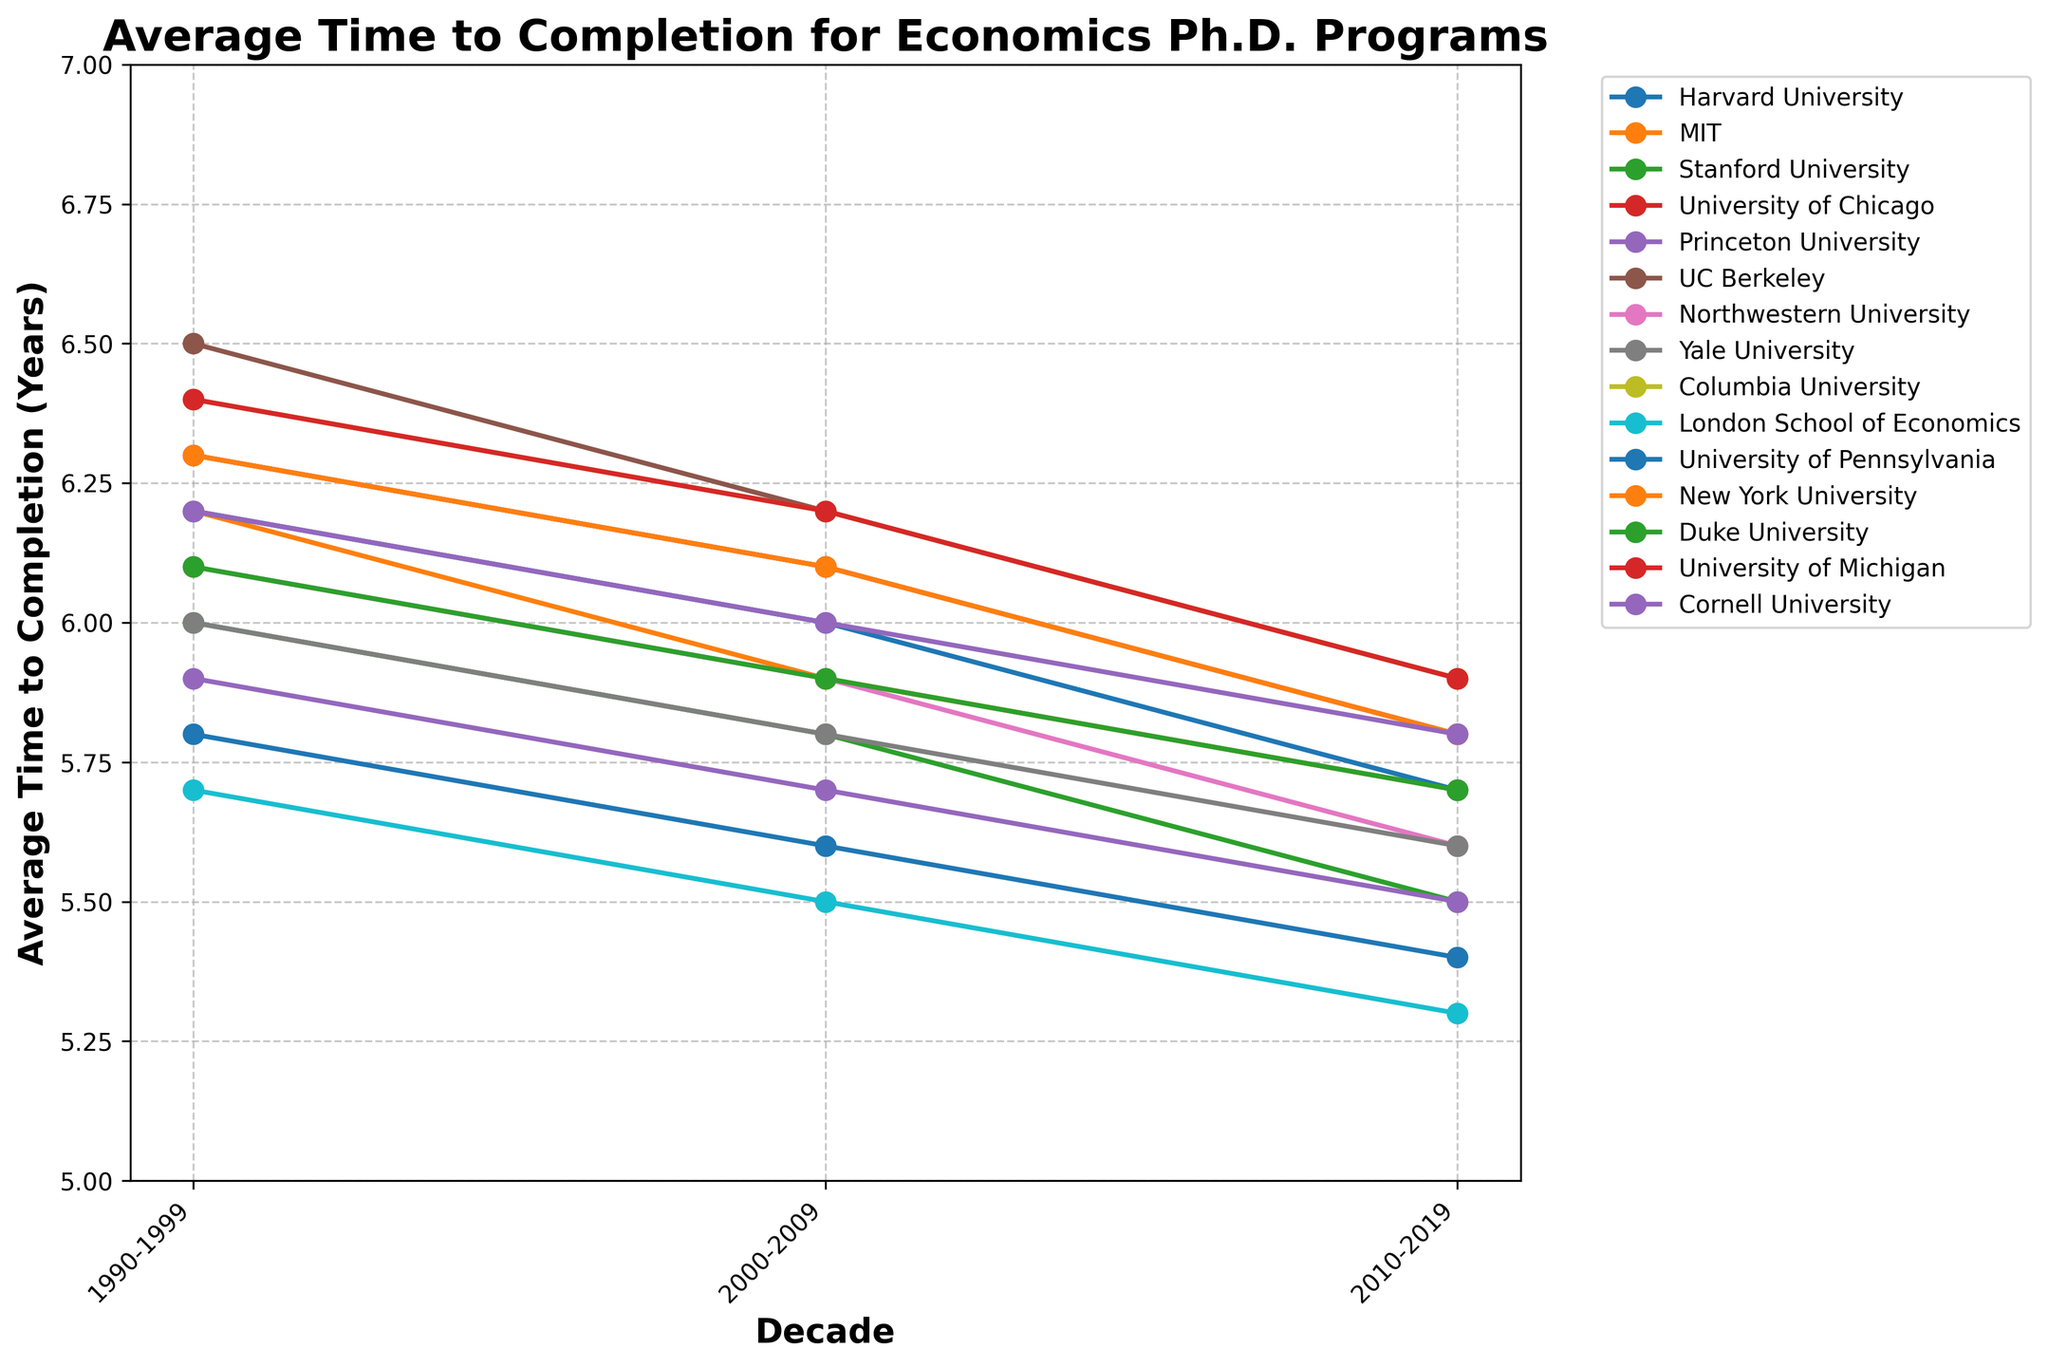What trend is observed in the average time to completion for Harvard University from 1990-2019? From the figure, the line for Harvard University shows a downward trend over the three decades. By 2010-2019, the average time to completion decreased to 5.4 years from 5.8 years in 1990-1999. This indicates a gradual shortening of the time required to complete an economics Ph.D. program at Harvard University.
Answer: Downward trend Which university had the shortest average completion time in the 2010-2019 period? To determine this, look at the y-values for each line in the 2010-2019 column. The line for the London School of Economics is the lowest, indicating that it had the shortest average time to completion of 5.3 years.
Answer: London School of Economics Comparing MIT and UC Berkeley, which had a greater decrease in average completion time from 1990-1999 to 2010-2019? Calculate the decrease for each university. MIT’s average completion time dropped from 6.2 to 5.7, a decrease of 0.5 years. UC Berkeley’s average completion time dropped from 6.5 to 5.9, a decrease of 0.6 years. Therefore, UC Berkeley had a greater decrease.
Answer: UC Berkeley What is the overall trend for the average time to completion for all universities combined? By observing the collective lines on the plot, most universities show a downward trend in the average time to completion from 1990-1999 to 2010-2019. This indicates a general trend of decreasing time required to complete economics Ph.D. programs across different universities.
Answer: Decreasing trend Which universities had the same average time to completion in the 2000-2009 period? Look at the y-values for lines in the 2000-2009 column. MIT, Yale University, Northwestern University, and Duke University each had an average time to completion of 5.9 years.
Answer: MIT, Yale University, Northwestern University, Duke University How did Stanford University’s average completion time change over the three decades? Refer to Stanford University’s line in the plot. The average time to completion decreased from 6.0 years in 1990-1999 to 5.5 years in 2010-2019.
Answer: Decreased What is the average time to completion for Ph.D. programs at Harvard University and MIT in the 2010-2019 period? Harvard University had an average completion time of 5.4 years, and MIT had an average completion time of 5.7 years. To find the average of these two values: (5.4 + 5.7) / 2 = 5.55 years.
Answer: 5.55 years Which university shows the largest overall decrease in average completion time from 1990-1999 to 2010-2019? Calculate the decrease for each university. The London School of Economics shows the largest decrease, from 5.7 years to 5.3 years, a decrease of 0.4 years. While other universities also show decreases, the London School of Economics has the most significant change.
Answer: London School of Economics Is there any university where the average completion time did not change significantly over the three decades? By examining the visual change in the lines for each university from 1990-1999 to 2010-2019, it appears that all universities show a noticeable decrease in average completion time. None of the lines remain relatively flat across the three decades.
Answer: No For which decade does the majority of the universities have the highest average time to completion? Observing the heights of the lines, most universities have the highest average time to completion during the 1990-1999 period. This is evident as the lines for many universities are higher in the 1990-1999 column compared to later periods.
Answer: 1990-1999 